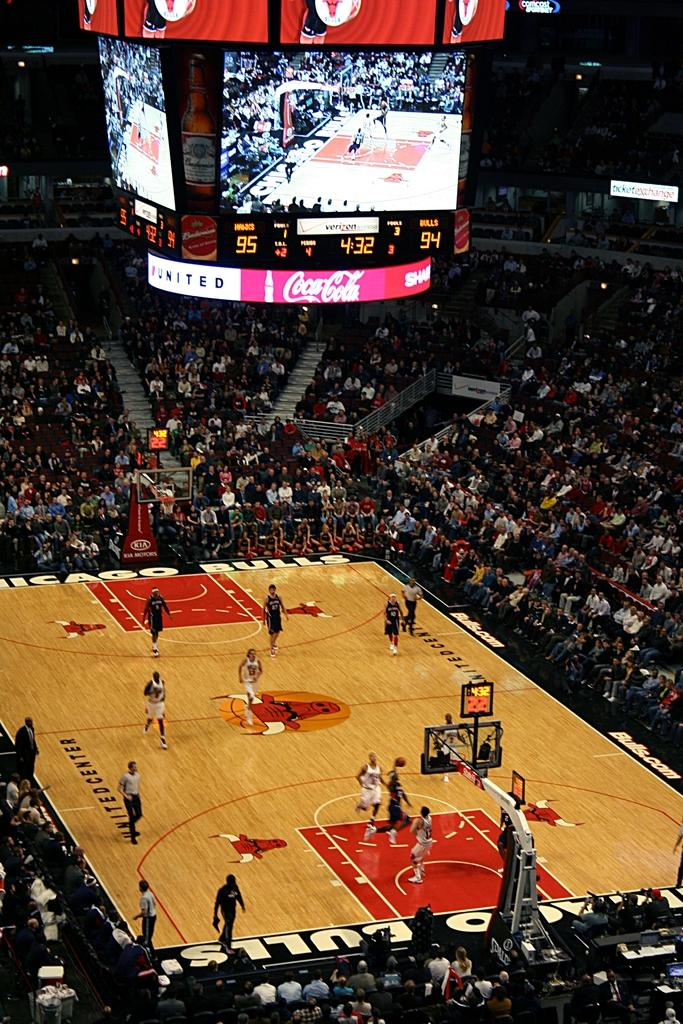<image>
Create a compact narrative representing the image presented. Basketball game with 4:32 left in the quarter. 